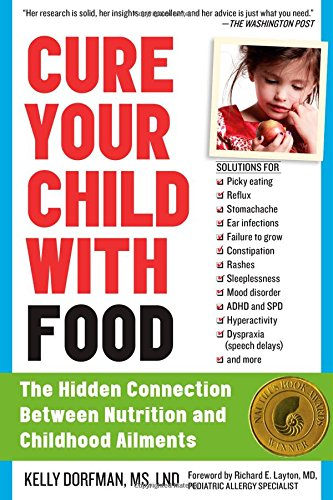Who wrote the foreword for this book, and what is their professional background? The foreword of the book is written by Richard E. Layton, MD, a noted pediatric allergy specialist, contributing his expertise to further underscore the book's themes on nutritional impacts on child health. 